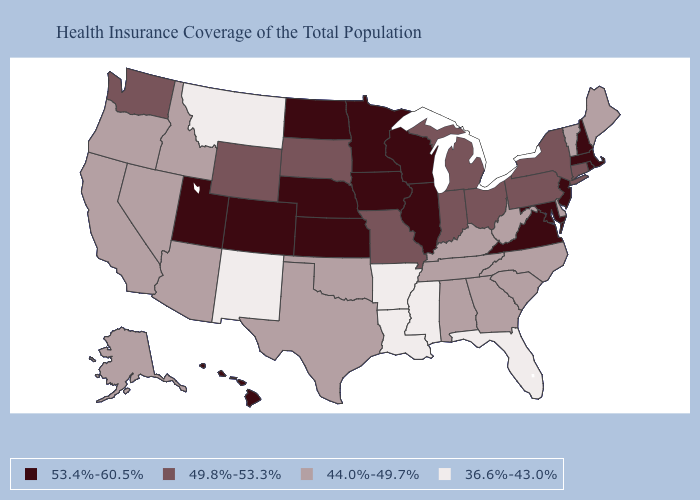What is the value of Kansas?
Concise answer only. 53.4%-60.5%. What is the lowest value in the USA?
Write a very short answer. 36.6%-43.0%. Does the first symbol in the legend represent the smallest category?
Quick response, please. No. What is the highest value in the USA?
Short answer required. 53.4%-60.5%. How many symbols are there in the legend?
Concise answer only. 4. Does Oregon have the same value as Delaware?
Answer briefly. Yes. What is the value of South Dakota?
Answer briefly. 49.8%-53.3%. Does Wyoming have a higher value than Nebraska?
Quick response, please. No. What is the lowest value in the USA?
Be succinct. 36.6%-43.0%. Which states hav the highest value in the South?
Short answer required. Maryland, Virginia. Name the states that have a value in the range 53.4%-60.5%?
Write a very short answer. Colorado, Hawaii, Illinois, Iowa, Kansas, Maryland, Massachusetts, Minnesota, Nebraska, New Hampshire, New Jersey, North Dakota, Rhode Island, Utah, Virginia, Wisconsin. What is the value of New Jersey?
Be succinct. 53.4%-60.5%. Does the map have missing data?
Quick response, please. No. Among the states that border Iowa , which have the lowest value?
Write a very short answer. Missouri, South Dakota. What is the highest value in states that border Vermont?
Answer briefly. 53.4%-60.5%. 